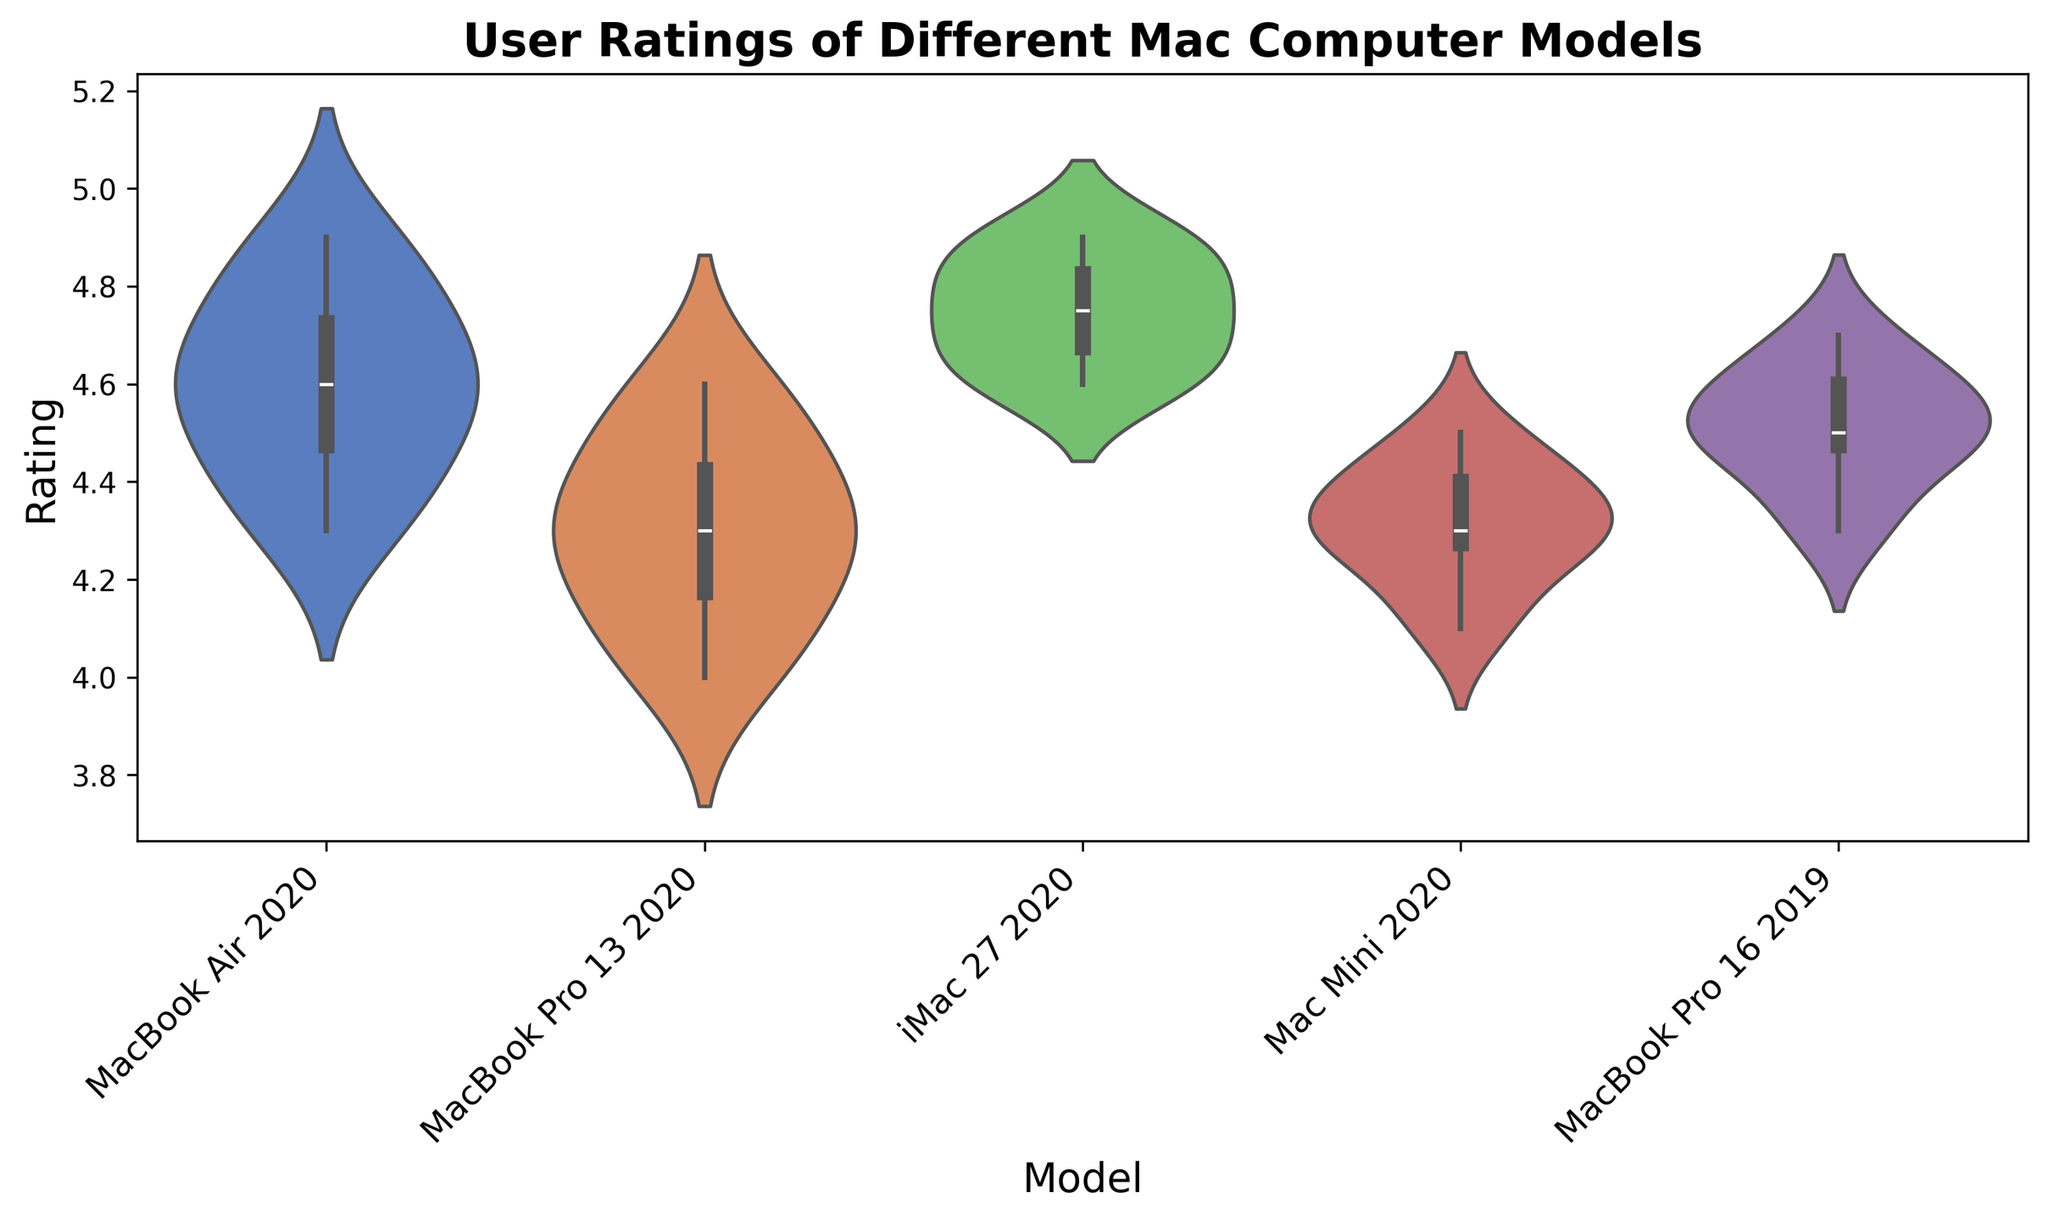What is the median user rating for the MacBook Air 2020? To find the median, you look for the middle value when the ratings are ordered. The ratings for MacBook Air 2020 are 4.3, 4.4, 4.5, 4.6, 4.6, 4.7, 4.8, 4.9. The median is the average of the 4th and 5th numbers: (4.6 + 4.6)/2 = 4.6
Answer: 4.6 Which model has the highest median rating? Determine the median rating of each model. From the violin plot, you can visually estimate that the iMac 27 2020 has the highest concentrations around higher ratings close to 4.75.
Answer: iMac 27 2020 How does the variability in ratings for MacBook Pro 13 2020 compare to Mac Mini 2020? Look at the width of the violins; MacBook Pro 13 2020's violin is wider, indicating more variability in user ratings compared to the narrower violin for Mac Mini 2020.
Answer: MacBook Pro 13 2020 has more variability Which model has the lowest minimum rating visible in the plot? The lowest visible rating can be identified by the lower tail of the violin plots. MacBook Pro 13 2020 shows the lowest minimum rating around 4.0.
Answer: MacBook Pro 13 2020 Are the ratings for the iMac 27 2020 more tightly clustered than those for MacBook Air 2020? Examine the width of the violin plots. The iMac 27 2020's violin plot is narrower than the MacBook Air 2020, indicating more tightly clustered ratings.
Answer: Yes What are the most frequent value ranges for the ratings of the MacBook Pro 16 2019? The thickest part of the violin plot for MacBook Pro 16 2019 indicates the most frequent ratings, which looks to be around 4.5 to 4.6.
Answer: 4.5 to 4.6 Compare the median ratings of MacBook Pro 13 2020 and Mac Mini 2020. Estimate the medians from the violin plots. The median for MacBook Pro 13 2020 is about 4.3, and for Mac Mini 2020 is also around 4.3.
Answer: Equal Are the ratings for MacBook Air 2020 more positively skewed than those for MacBook Pro 16 2019? Examine the shape of the violin plots. The MacBook Air 2020 shows a right (positive) skew with more ratings clustering towards higher values than the MacBook Pro 16 2019's more symmetrical distribution.
Answer: Yes Which model exhibits the second widest range of ratings? Look at the length of the violins. After MacBook Pro 13 2020, the model with the second widest range is MacBook Air 2020.
Answer: MacBook Air 2020 